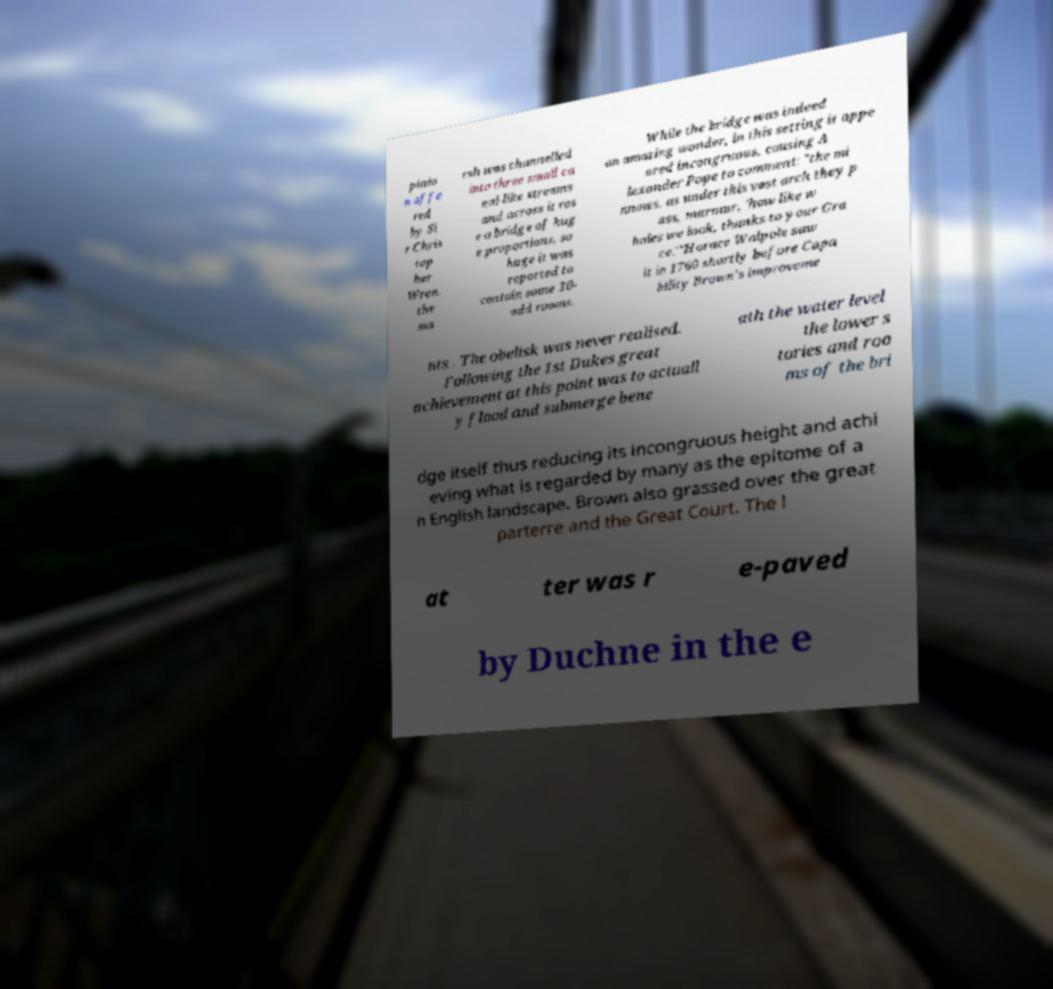There's text embedded in this image that I need extracted. Can you transcribe it verbatim? pinio n offe red by Si r Chris top her Wren, the ma rsh was channelled into three small ca nal-like streams and across it ros e a bridge of hug e proportions, so huge it was reported to contain some 30- odd rooms. While the bridge was indeed an amazing wonder, in this setting it appe ared incongruous, causing A lexander Pope to comment: "the mi nnows, as under this vast arch they p ass, murmur, 'how like w hales we look, thanks to your Gra ce.'"Horace Walpole saw it in 1760 shortly before Capa bility Brown's improveme nts . The obelisk was never realised. Following the 1st Dukes great achievement at this point was to actuall y flood and submerge bene ath the water level the lower s tories and roo ms of the bri dge itself thus reducing its incongruous height and achi eving what is regarded by many as the epitome of a n English landscape. Brown also grassed over the great parterre and the Great Court. The l at ter was r e-paved by Duchne in the e 